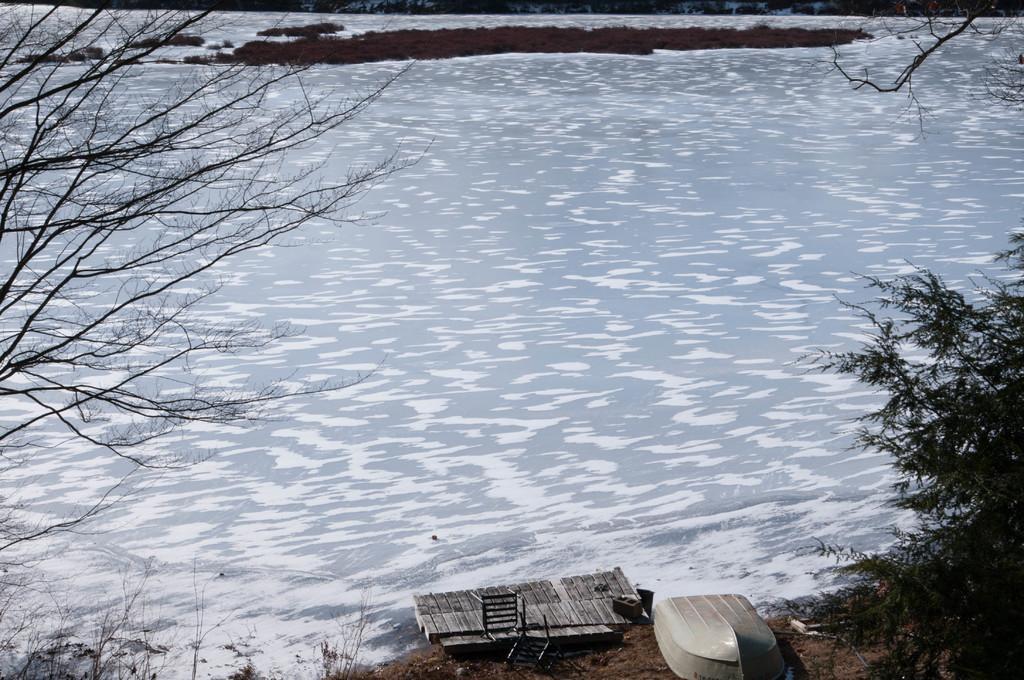How would you summarize this image in a sentence or two? In the foreground of this picture, there is a chair near dock,a boat on the ground and trees on either side of the image. In the background, there is a rock and the water. 